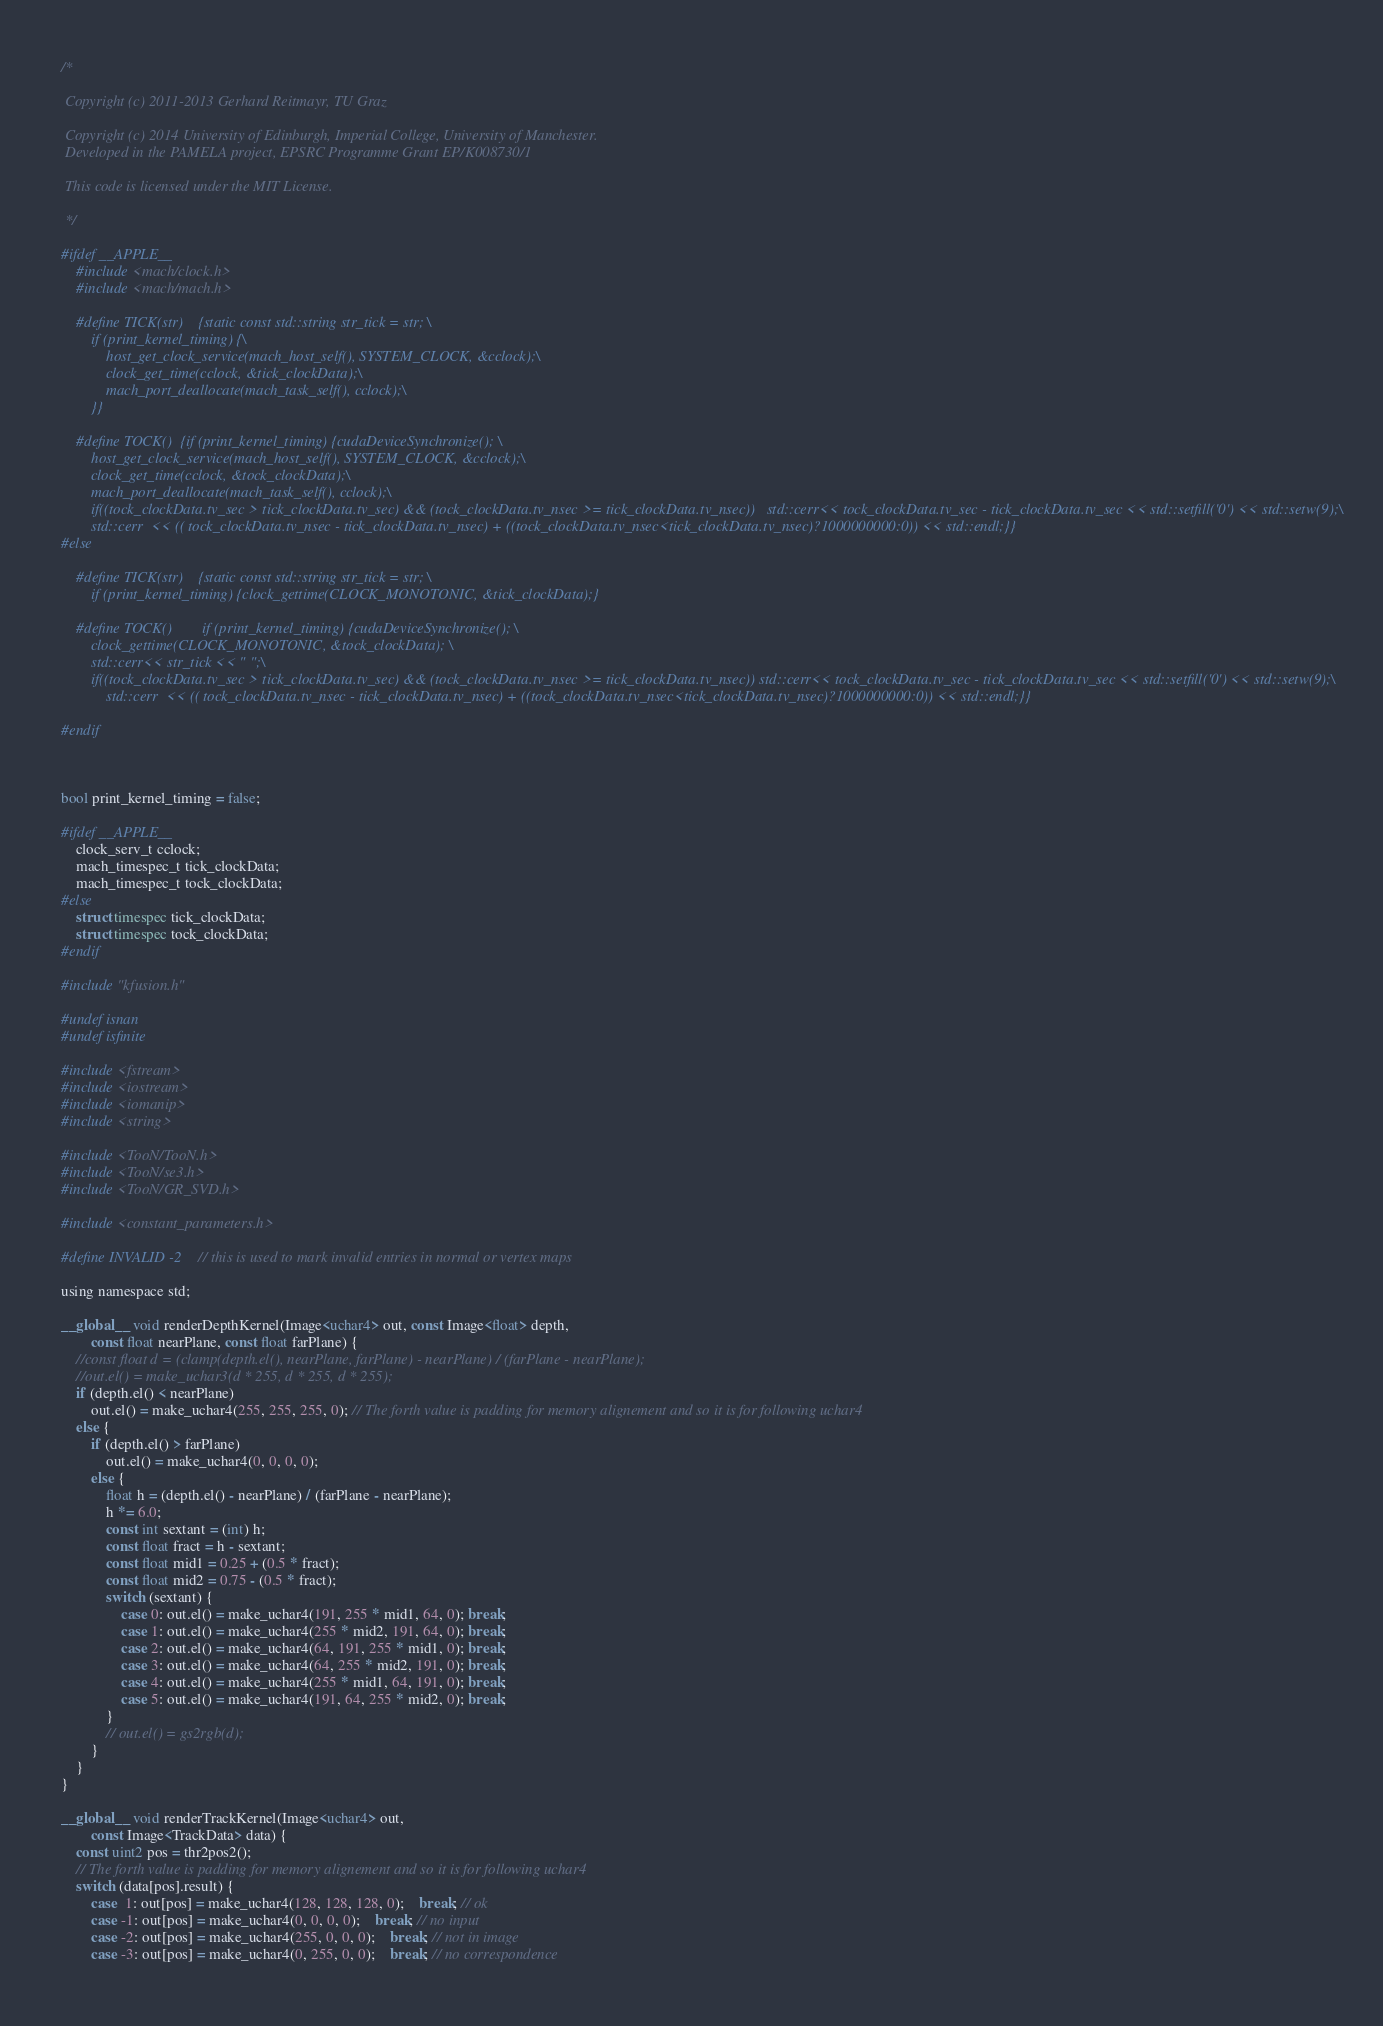Convert code to text. <code><loc_0><loc_0><loc_500><loc_500><_Cuda_>/*

 Copyright (c) 2011-2013 Gerhard Reitmayr, TU Graz

 Copyright (c) 2014 University of Edinburgh, Imperial College, University of Manchester.
 Developed in the PAMELA project, EPSRC Programme Grant EP/K008730/1

 This code is licensed under the MIT License.

 */

#ifdef __APPLE__
	#include <mach/clock.h>
	#include <mach/mach.h>

	#define TICK(str)    {static const std::string str_tick = str; \
		if (print_kernel_timing) {\
		    host_get_clock_service(mach_host_self(), SYSTEM_CLOCK, &cclock);\
		    clock_get_time(cclock, &tick_clockData);\
		    mach_port_deallocate(mach_task_self(), cclock);\
		}}

	#define TOCK()  {if (print_kernel_timing) {cudaDeviceSynchronize(); \
		host_get_clock_service(mach_host_self(), SYSTEM_CLOCK, &cclock);\
		clock_get_time(cclock, &tock_clockData);\
		mach_port_deallocate(mach_task_self(), cclock);\
		if((tock_clockData.tv_sec > tick_clockData.tv_sec) && (tock_clockData.tv_nsec >= tick_clockData.tv_nsec))   std::cerr<< tock_clockData.tv_sec - tick_clockData.tv_sec << std::setfill('0') << std::setw(9);\
		std::cerr  << (( tock_clockData.tv_nsec - tick_clockData.tv_nsec) + ((tock_clockData.tv_nsec<tick_clockData.tv_nsec)?1000000000:0)) << std::endl;}}
#else
	
	#define TICK(str)    {static const std::string str_tick = str; \
		if (print_kernel_timing) {clock_gettime(CLOCK_MONOTONIC, &tick_clockData);}
	
	#define TOCK()        if (print_kernel_timing) {cudaDeviceSynchronize(); \
		clock_gettime(CLOCK_MONOTONIC, &tock_clockData); \
		std::cerr<< str_tick << " ";\
		if((tock_clockData.tv_sec > tick_clockData.tv_sec) && (tock_clockData.tv_nsec >= tick_clockData.tv_nsec)) std::cerr<< tock_clockData.tv_sec - tick_clockData.tv_sec << std::setfill('0') << std::setw(9);\
		    std::cerr  << (( tock_clockData.tv_nsec - tick_clockData.tv_nsec) + ((tock_clockData.tv_nsec<tick_clockData.tv_nsec)?1000000000:0)) << std::endl;}}

#endif



bool print_kernel_timing = false;

#ifdef __APPLE__
	clock_serv_t cclock;
	mach_timespec_t tick_clockData;
	mach_timespec_t tock_clockData;
#else
	struct timespec tick_clockData;
	struct timespec tock_clockData;
#endif

#include "kfusion.h"

#undef isnan
#undef isfinite

#include <fstream>
#include <iostream>
#include <iomanip>
#include <string>

#include <TooN/TooN.h>
#include <TooN/se3.h>
#include <TooN/GR_SVD.h>

#include <constant_parameters.h>

#define INVALID -2   // this is used to mark invalid entries in normal or vertex maps

using namespace std;

__global__ void renderDepthKernel(Image<uchar4> out, const Image<float> depth,
		const float nearPlane, const float farPlane) {
	//const float d = (clamp(depth.el(), nearPlane, farPlane) - nearPlane) / (farPlane - nearPlane);
	//out.el() = make_uchar3(d * 255, d * 255, d * 255);
	if (depth.el() < nearPlane)
		out.el() = make_uchar4(255, 255, 255, 0); // The forth value is padding for memory alignement and so it is for following uchar4
	else {
		if (depth.el() > farPlane)
			out.el() = make_uchar4(0, 0, 0, 0); 
		else {
			float h = (depth.el() - nearPlane) / (farPlane - nearPlane);
			h *= 6.0;
			const int sextant = (int) h;
			const float fract = h - sextant;
			const float mid1 = 0.25 + (0.5 * fract);
			const float mid2 = 0.75 - (0.5 * fract);
			switch (sextant) {
			    case 0: out.el() = make_uchar4(191, 255 * mid1, 64, 0); break;
			    case 1: out.el() = make_uchar4(255 * mid2, 191, 64, 0); break;
			    case 2: out.el() = make_uchar4(64, 191, 255 * mid1, 0); break;
			    case 3: out.el() = make_uchar4(64, 255 * mid2, 191, 0); break;
			    case 4: out.el() = make_uchar4(255 * mid1, 64, 191, 0); break;
			    case 5: out.el() = make_uchar4(191, 64, 255 * mid2, 0); break;
			}
			// out.el() = gs2rgb(d);
		}
	}
}

__global__ void renderTrackKernel(Image<uchar4> out,
		const Image<TrackData> data) {
	const uint2 pos = thr2pos2();
	// The forth value is padding for memory alignement and so it is for following uchar4
	switch (data[pos].result) {
	    case  1: out[pos] = make_uchar4(128, 128, 128, 0);	break; // ok
	    case -1: out[pos] = make_uchar4(0, 0, 0, 0);	break; // no input 
	    case -2: out[pos] = make_uchar4(255, 0, 0, 0);	break; // not in image 
	    case -3: out[pos] = make_uchar4(0, 255, 0, 0);	break; // no correspondence</code> 